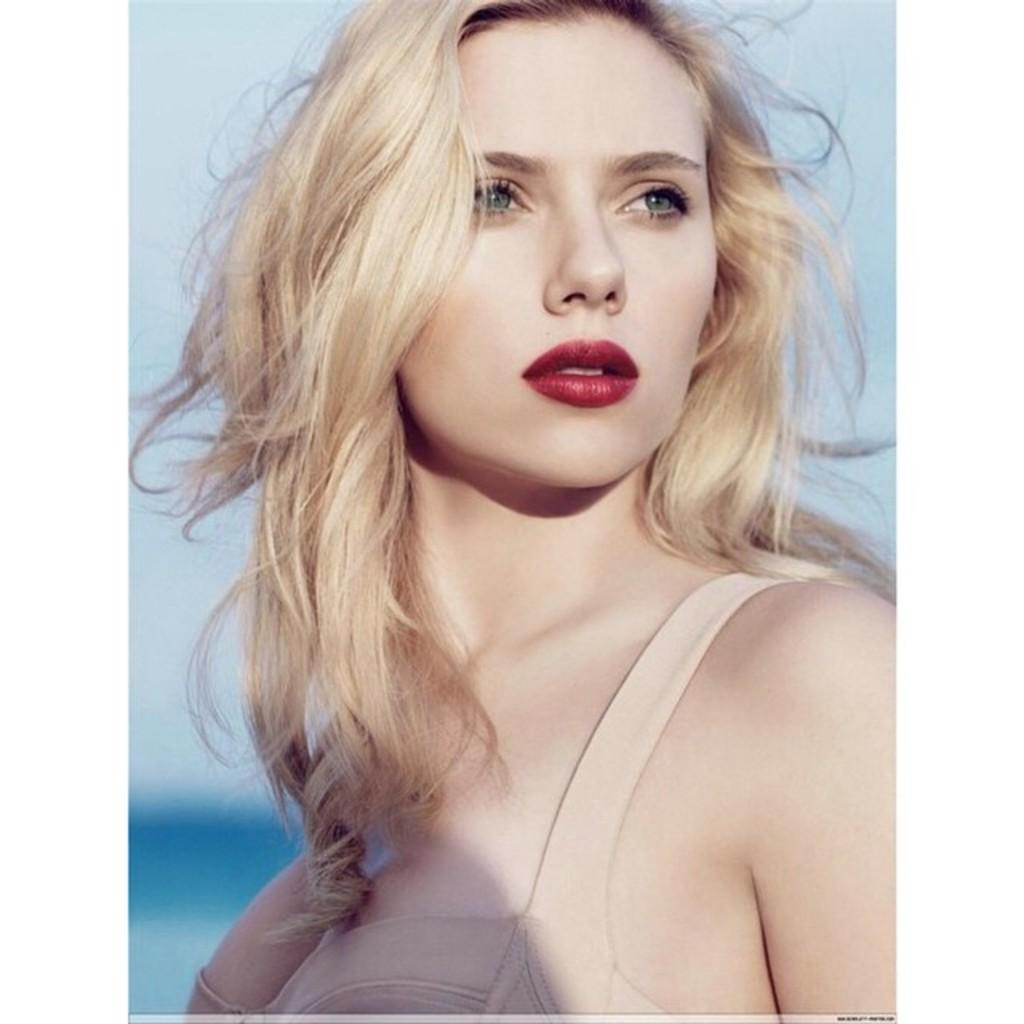Who is the main subject in the image? There is a woman in the center of the image. What is the woman doing in the image? The woman is standing. What can be seen in the background of the image? There is sky visible in the background of the image. How many cacti are growing in the hole next to the woman in the image? There are no cacti or holes present in the image; it only features a woman standing against a sky background. 